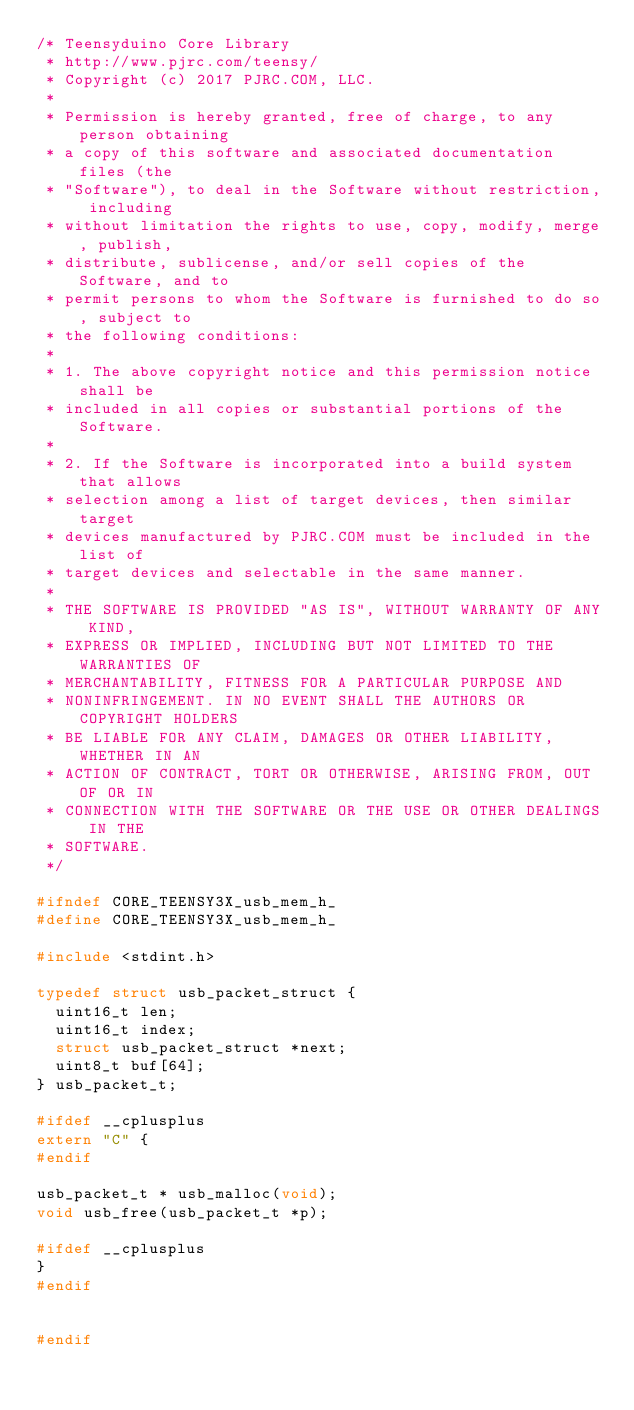Convert code to text. <code><loc_0><loc_0><loc_500><loc_500><_C_>/* Teensyduino Core Library
 * http://www.pjrc.com/teensy/
 * Copyright (c) 2017 PJRC.COM, LLC.
 *
 * Permission is hereby granted, free of charge, to any person obtaining
 * a copy of this software and associated documentation files (the
 * "Software"), to deal in the Software without restriction, including
 * without limitation the rights to use, copy, modify, merge, publish,
 * distribute, sublicense, and/or sell copies of the Software, and to
 * permit persons to whom the Software is furnished to do so, subject to
 * the following conditions:
 *
 * 1. The above copyright notice and this permission notice shall be
 * included in all copies or substantial portions of the Software.
 *
 * 2. If the Software is incorporated into a build system that allows
 * selection among a list of target devices, then similar target
 * devices manufactured by PJRC.COM must be included in the list of
 * target devices and selectable in the same manner.
 *
 * THE SOFTWARE IS PROVIDED "AS IS", WITHOUT WARRANTY OF ANY KIND,
 * EXPRESS OR IMPLIED, INCLUDING BUT NOT LIMITED TO THE WARRANTIES OF
 * MERCHANTABILITY, FITNESS FOR A PARTICULAR PURPOSE AND
 * NONINFRINGEMENT. IN NO EVENT SHALL THE AUTHORS OR COPYRIGHT HOLDERS
 * BE LIABLE FOR ANY CLAIM, DAMAGES OR OTHER LIABILITY, WHETHER IN AN
 * ACTION OF CONTRACT, TORT OR OTHERWISE, ARISING FROM, OUT OF OR IN
 * CONNECTION WITH THE SOFTWARE OR THE USE OR OTHER DEALINGS IN THE
 * SOFTWARE.
 */

#ifndef CORE_TEENSY3X_usb_mem_h_
#define CORE_TEENSY3X_usb_mem_h_

#include <stdint.h>

typedef struct usb_packet_struct {
	uint16_t len;
	uint16_t index;
	struct usb_packet_struct *next;
	uint8_t buf[64];
} usb_packet_t;

#ifdef __cplusplus
extern "C" {
#endif

usb_packet_t * usb_malloc(void);
void usb_free(usb_packet_t *p);

#ifdef __cplusplus
}
#endif


#endif
</code> 